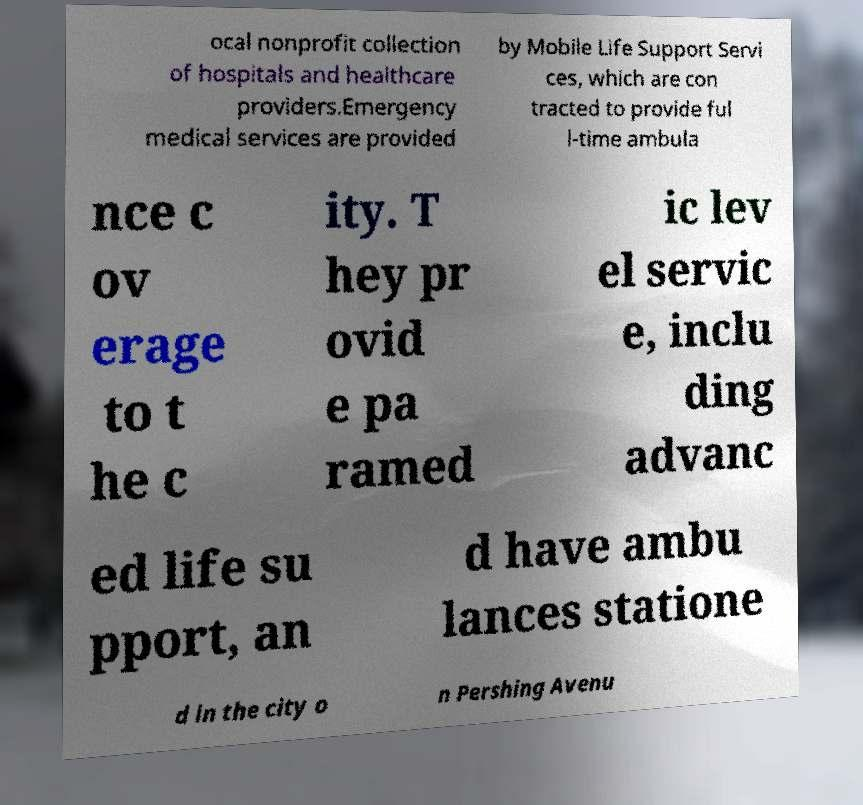Could you extract and type out the text from this image? ocal nonprofit collection of hospitals and healthcare providers.Emergency medical services are provided by Mobile Life Support Servi ces, which are con tracted to provide ful l-time ambula nce c ov erage to t he c ity. T hey pr ovid e pa ramed ic lev el servic e, inclu ding advanc ed life su pport, an d have ambu lances statione d in the city o n Pershing Avenu 